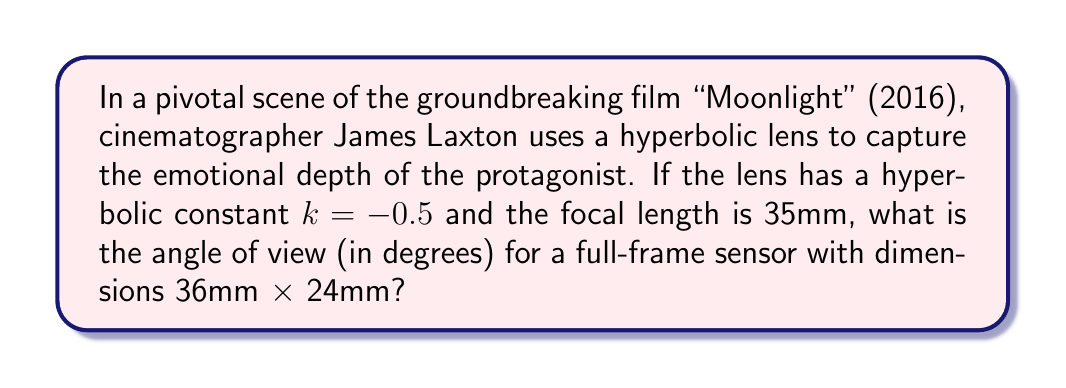Show me your answer to this math problem. To solve this problem, we'll follow these steps:

1) In hyperbolic geometry, the angle of view (AOV) is given by the formula:

   $$AOV = 2 \arctan\left(\frac{d}{2f\sqrt{-k}}\right)$$

   Where $d$ is the diagonal of the sensor, $f$ is the focal length, and $k$ is the hyperbolic constant.

2) First, we need to calculate the diagonal of the full-frame sensor:

   $$d = \sqrt{36^2 + 24^2} = \sqrt{1296 + 576} = \sqrt{1872} \approx 43.27 \text{ mm}$$

3) Now we have all the values:
   $d \approx 43.27$ mm
   $f = 35$ mm
   $k = -0.5$

4) Let's substitute these into our formula:

   $$AOV = 2 \arctan\left(\frac{43.27}{2 \cdot 35 \cdot \sqrt{0.5}}\right)$$

5) Simplify:

   $$AOV = 2 \arctan\left(\frac{43.27}{70 \cdot 0.7071}\right) = 2 \arctan\left(\frac{43.27}{49.497}\right)$$

6) Calculate:

   $$AOV = 2 \arctan(0.8742) \approx 2 \cdot 41.17° = 82.34°$$

Thus, the angle of view is approximately 82.34 degrees.
Answer: 82.34° 